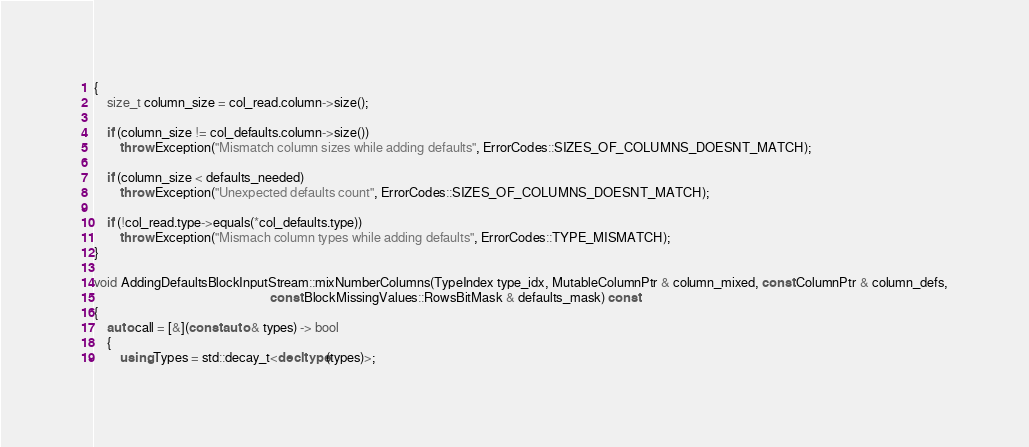Convert code to text. <code><loc_0><loc_0><loc_500><loc_500><_C++_>{
    size_t column_size = col_read.column->size();

    if (column_size != col_defaults.column->size())
        throw Exception("Mismatch column sizes while adding defaults", ErrorCodes::SIZES_OF_COLUMNS_DOESNT_MATCH);

    if (column_size < defaults_needed)
        throw Exception("Unexpected defaults count", ErrorCodes::SIZES_OF_COLUMNS_DOESNT_MATCH);

    if (!col_read.type->equals(*col_defaults.type))
        throw Exception("Mismach column types while adding defaults", ErrorCodes::TYPE_MISMATCH);
}

void AddingDefaultsBlockInputStream::mixNumberColumns(TypeIndex type_idx, MutableColumnPtr & column_mixed, const ColumnPtr & column_defs,
                                                      const BlockMissingValues::RowsBitMask & defaults_mask) const
{
    auto call = [&](const auto & types) -> bool
    {
        using Types = std::decay_t<decltype(types)>;</code> 